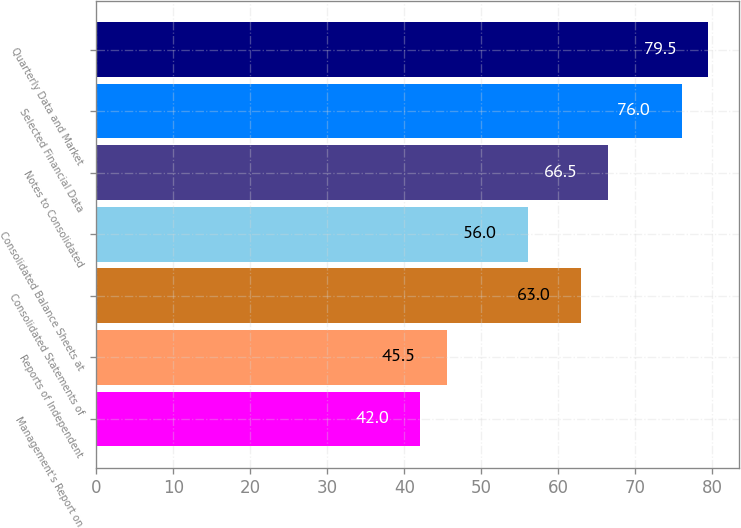<chart> <loc_0><loc_0><loc_500><loc_500><bar_chart><fcel>Management's Report on<fcel>Reports of Independent<fcel>Consolidated Statements of<fcel>Consolidated Balance Sheets at<fcel>Notes to Consolidated<fcel>Selected Financial Data<fcel>Quarterly Data and Market<nl><fcel>42<fcel>45.5<fcel>63<fcel>56<fcel>66.5<fcel>76<fcel>79.5<nl></chart> 